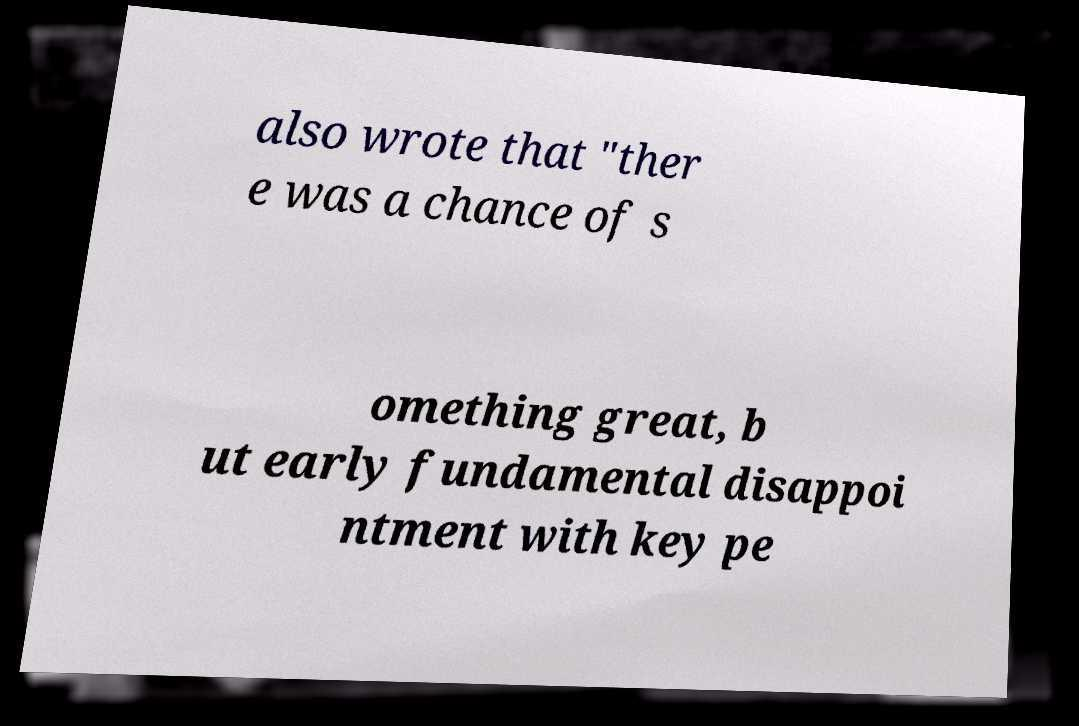There's text embedded in this image that I need extracted. Can you transcribe it verbatim? also wrote that "ther e was a chance of s omething great, b ut early fundamental disappoi ntment with key pe 